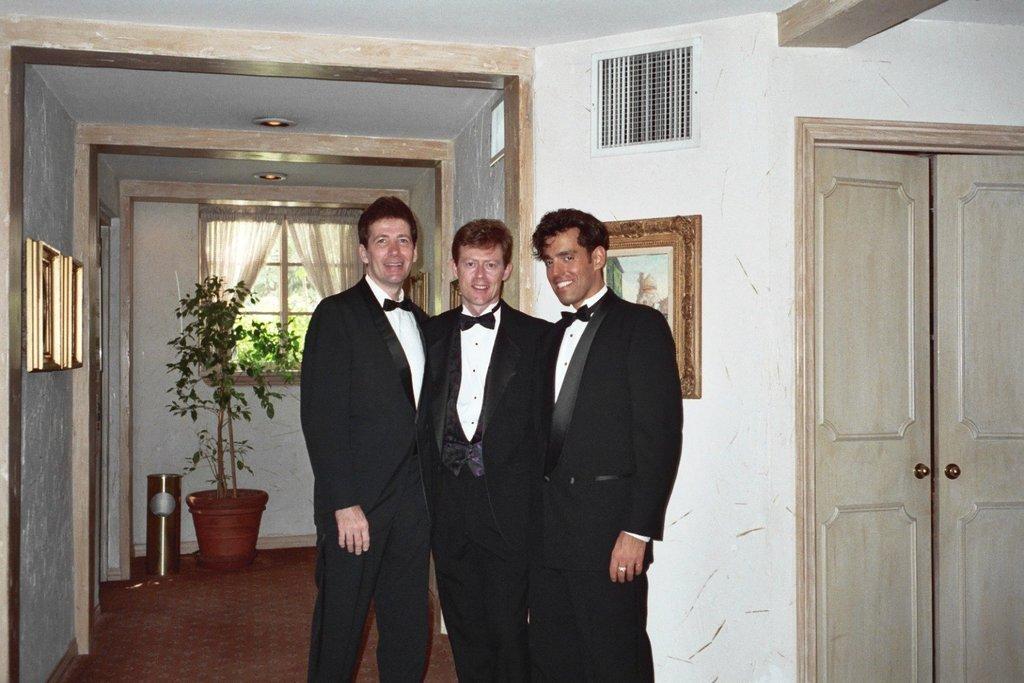Could you give a brief overview of what you see in this image? In the picture I can see three men are standing and smiling. These three men are wearing black color suits. In the background I can see a plant pot, a window, curtains, photos on the wall, lights on the ceiling, doors and some other objects on the floor. 